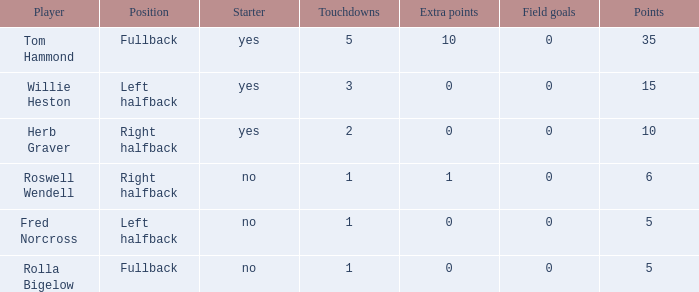How many extra points did right halfback Roswell Wendell have? 1.0. 